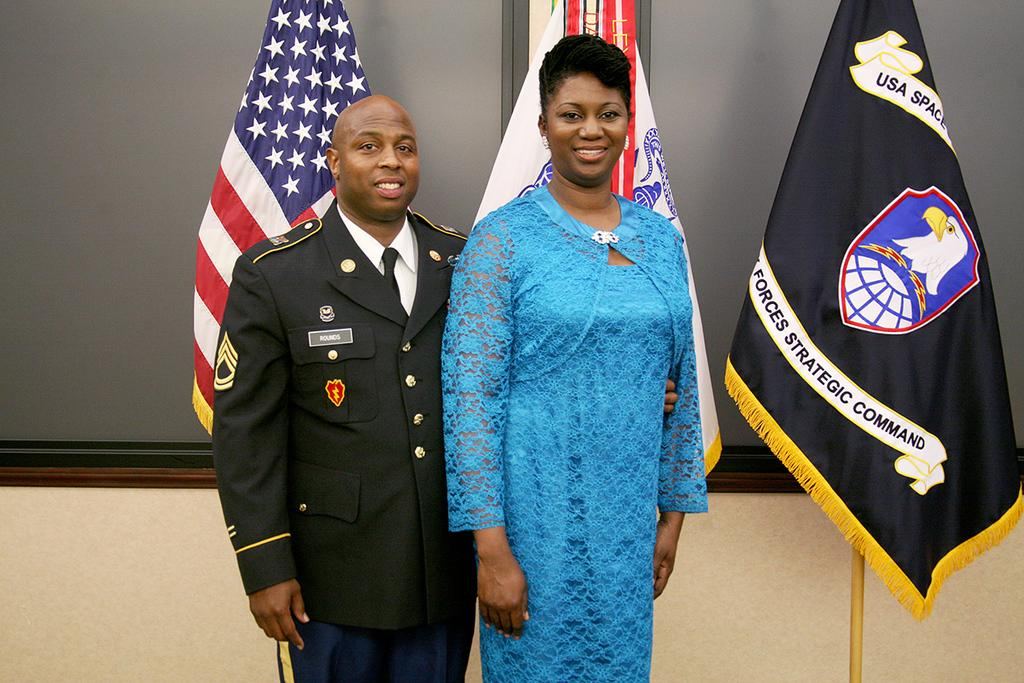<image>
Offer a succinct explanation of the picture presented. A gentleman and lady are standing in front of several flags and one says "strategic command" toward the bottom. 